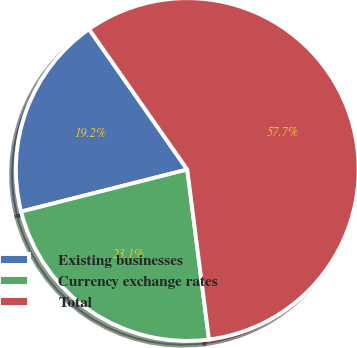<chart> <loc_0><loc_0><loc_500><loc_500><pie_chart><fcel>Existing businesses<fcel>Currency exchange rates<fcel>Total<nl><fcel>19.23%<fcel>23.08%<fcel>57.69%<nl></chart> 